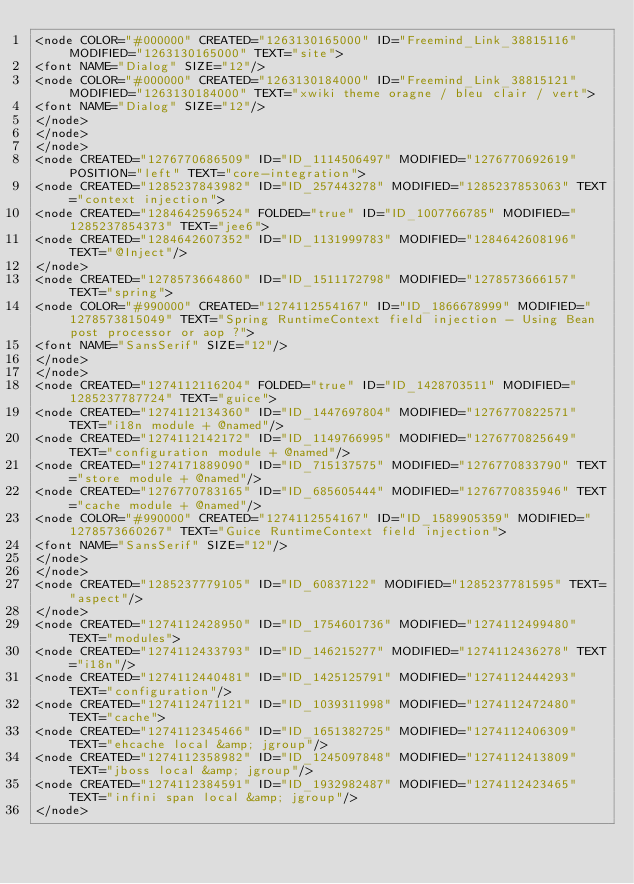<code> <loc_0><loc_0><loc_500><loc_500><_ObjectiveC_><node COLOR="#000000" CREATED="1263130165000" ID="Freemind_Link_38815116" MODIFIED="1263130165000" TEXT="site">
<font NAME="Dialog" SIZE="12"/>
<node COLOR="#000000" CREATED="1263130184000" ID="Freemind_Link_38815121" MODIFIED="1263130184000" TEXT="xwiki theme oragne / bleu clair / vert">
<font NAME="Dialog" SIZE="12"/>
</node>
</node>
</node>
<node CREATED="1276770686509" ID="ID_1114506497" MODIFIED="1276770692619" POSITION="left" TEXT="core-integration">
<node CREATED="1285237843982" ID="ID_257443278" MODIFIED="1285237853063" TEXT="context injection">
<node CREATED="1284642596524" FOLDED="true" ID="ID_1007766785" MODIFIED="1285237854373" TEXT="jee6">
<node CREATED="1284642607352" ID="ID_1131999783" MODIFIED="1284642608196" TEXT="@Inject"/>
</node>
<node CREATED="1278573664860" ID="ID_1511172798" MODIFIED="1278573666157" TEXT="spring">
<node COLOR="#990000" CREATED="1274112554167" ID="ID_1866678999" MODIFIED="1278573815049" TEXT="Spring RuntimeContext field injection - Using Bean post processor or aop ?">
<font NAME="SansSerif" SIZE="12"/>
</node>
</node>
<node CREATED="1274112116204" FOLDED="true" ID="ID_1428703511" MODIFIED="1285237787724" TEXT="guice">
<node CREATED="1274112134360" ID="ID_1447697804" MODIFIED="1276770822571" TEXT="i18n module + @named"/>
<node CREATED="1274112142172" ID="ID_1149766995" MODIFIED="1276770825649" TEXT="configuration module + @named"/>
<node CREATED="1274171889090" ID="ID_715137575" MODIFIED="1276770833790" TEXT="store module + @named"/>
<node CREATED="1276770783165" ID="ID_685605444" MODIFIED="1276770835946" TEXT="cache module + @named"/>
<node COLOR="#990000" CREATED="1274112554167" ID="ID_1589905359" MODIFIED="1278573660267" TEXT="Guice RuntimeContext field injection">
<font NAME="SansSerif" SIZE="12"/>
</node>
</node>
<node CREATED="1285237779105" ID="ID_60837122" MODIFIED="1285237781595" TEXT="aspect"/>
</node>
<node CREATED="1274112428950" ID="ID_1754601736" MODIFIED="1274112499480" TEXT="modules">
<node CREATED="1274112433793" ID="ID_146215277" MODIFIED="1274112436278" TEXT="i18n"/>
<node CREATED="1274112440481" ID="ID_1425125791" MODIFIED="1274112444293" TEXT="configuration"/>
<node CREATED="1274112471121" ID="ID_1039311998" MODIFIED="1274112472480" TEXT="cache">
<node CREATED="1274112345466" ID="ID_1651382725" MODIFIED="1274112406309" TEXT="ehcache local &amp; jgroup"/>
<node CREATED="1274112358982" ID="ID_1245097848" MODIFIED="1274112413809" TEXT="jboss local &amp; jgroup"/>
<node CREATED="1274112384591" ID="ID_1932982487" MODIFIED="1274112423465" TEXT="infini span local &amp; jgroup"/>
</node></code> 